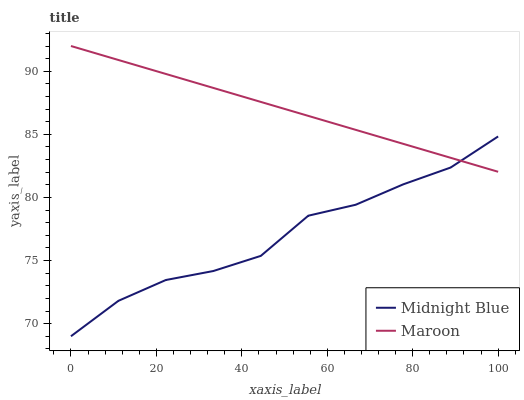Does Midnight Blue have the minimum area under the curve?
Answer yes or no. Yes. Does Maroon have the maximum area under the curve?
Answer yes or no. Yes. Does Maroon have the minimum area under the curve?
Answer yes or no. No. Is Maroon the smoothest?
Answer yes or no. Yes. Is Midnight Blue the roughest?
Answer yes or no. Yes. Is Maroon the roughest?
Answer yes or no. No. Does Midnight Blue have the lowest value?
Answer yes or no. Yes. Does Maroon have the lowest value?
Answer yes or no. No. Does Maroon have the highest value?
Answer yes or no. Yes. Does Maroon intersect Midnight Blue?
Answer yes or no. Yes. Is Maroon less than Midnight Blue?
Answer yes or no. No. Is Maroon greater than Midnight Blue?
Answer yes or no. No. 